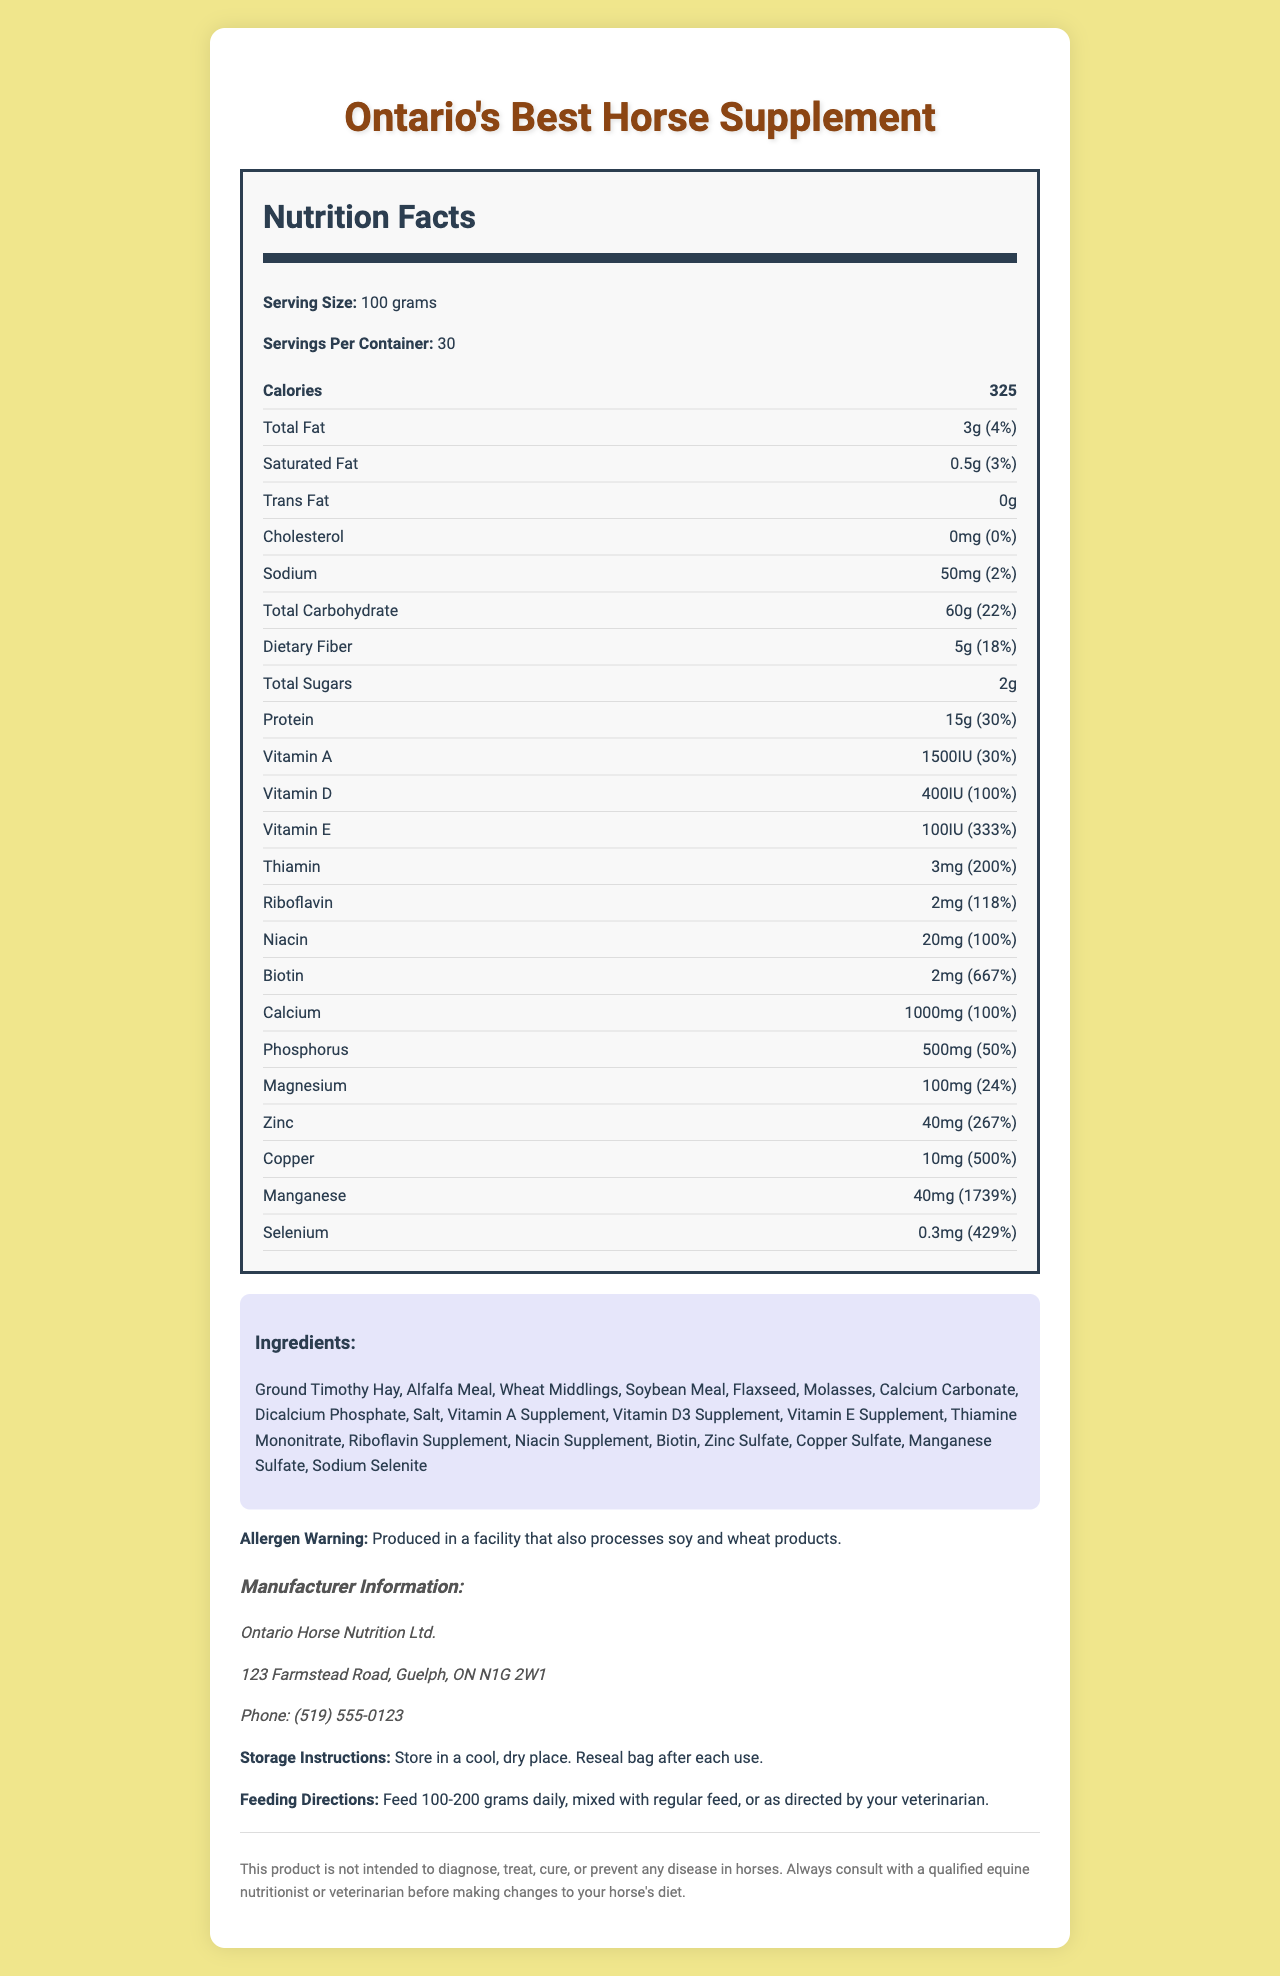how many calories are there per serving? The nutrition label indicates that there are 325 calories per serving.
Answer: 325 what is the serving size? The serving size is indicated as 100 grams in the document.
Answer: 100 grams how many servings are there per container? The document states that there are 30 servings per container.
Answer: 30 how much protein is in each serving? The document lists 15 grams of protein per serving.
Answer: 15 grams what percentage of the daily value is thiamin? The thiamin amount and daily value percentage are shown as 3mg and 200%, respectively.
Answer: 200% what is the main ingredient in the supplement? The first ingredient listed is Ground Timothy Hay, which typically indicates it is the main ingredient.
Answer: Ground Timothy Hay how much copper is present per serving? Copper is listed as having 10mg per serving with a daily value of 500%.
Answer: 10mg is there any trans fat in the supplement? The document denotes 0g of trans fat per serving.
Answer: No what is the allergen warning for this product? The allergen warning states that it is produced in a facility that handles soy and wheat.
Answer: Produced in a facility that also processes soy and wheat products. what are the storage instructions for this product? The document instructs to store the product in a cool, dry place and to reseal the bag after each use.
Answer: Store in a cool, dry place. Reseal bag after each use. which vitamin is present in the highest daily value percentage? A. Vitamin A B. Vitamin D C. Vitamin E D. Vitamin B Vitamin E has a daily value percentage of 333%, the highest among the listed vitamins.
Answer: C. Vitamin E what is the amount of dietary fiber per serving? A. 3g B. 5g C. 10g The nutrition label shows there are 5 grams of dietary fiber per serving.
Answer: B. 5g what form of niacin is included in the ingredients? A. Niacinamid B. Niacin C. Nicotinic Acid The document lists Niacin Supplement under the ingredients.
Answer: B. Niacin how much selenium is in each serving? A. 0.2mg B. 0.3mg C. 1mg D. 2mg Selenium is listed as 0.3mg per serving with a daily value percentage of 429%.
Answer: B. 0.3mg is this product made for diagnosing or treating diseases in horses? The disclaimer clearly states that the product is not intended to diagnose, treat, cure, or prevent any disease in horses.
Answer: No describe the main idea of the document The document is comprehensive and includes essential information about the horse supplement, its nutritional content, ingredients, storage, and use instructions.
Answer: The document provides detailed nutritional information for "Ontario's Best Horse Supplement", including serving size, servings per container, calories, and nutrient content per serving. It also lists ingredients, allergen warnings, manufacturer information, storage instructions, feeding directions, and a disclaimer. what type of product is this supplement designed for? The document provides detailed nutritional information but doesn't specify the exact type of horses this product is designed for (e.g., performance horses, senior horses, etc.).
Answer: Cannot be determined 